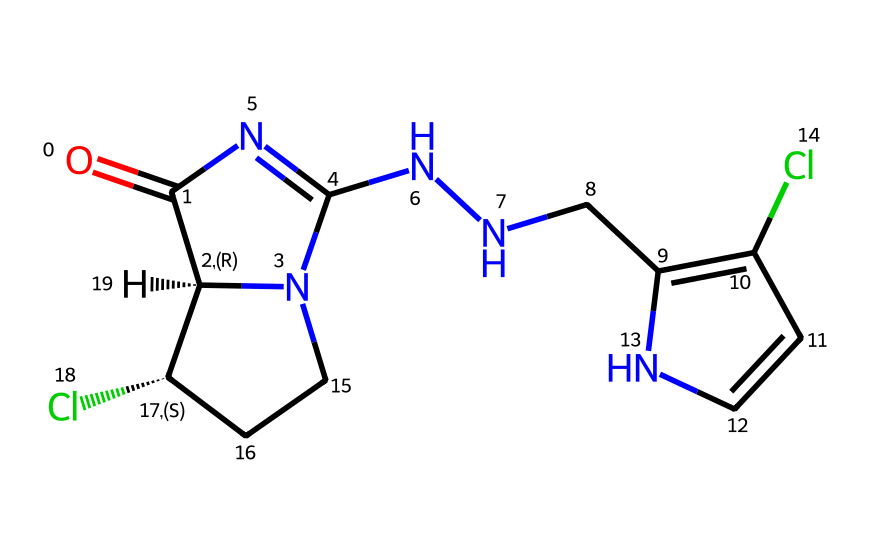What is the molecular formula of this neonicotinoid? To derive the molecular formula, we count all the individual atoms from the SMILES representation. In this structure, there are 12 carbon (C) atoms, 14 hydrogen (H) atoms, 4 nitrogen (N) atoms, and 2 chlorine (Cl) atoms. Thus, the molecular formula is C12H14Cl2N4.
Answer: C12H14Cl2N4 How many rings are present in this neonicotinoid structure? We can identify rings by observing the structure from the SMILES notation. In the representation, we see two pairs of numbers indicating ring closures (1 and 2); therefore, there are two rings in total in this compound.
Answer: 2 Which functional groups are evident in this neonicotinoid? By examining the structure, we look for distinct functional groups. The SMILES suggests both amine (due to the nitrogen atoms), ketone (the carbonyl C=O), and aromatic characteristics (due to the C=C double bond); thus, the functional groups identified are amine, ketone, and aromatic.
Answer: amine, ketone, aromatic What type of chemical is this structure classified as? Considering its structure and the presence of certain functional groups, the compound contains characteristics typical of neonicotinoids, which are synthetic pesticides. Therefore, this structure is classified as a neonicotinoid pesticide based on its functional composition and usage.
Answer: neonicotinoid pesticide What impact does this neonicotinoid have on bee populations? Research indicates that neonicotinoids, like this one, adversely affect bee populations primarily through neurotoxic effects that impair foraging behavior and navigational capabilities. This connection between the chemical's neurotoxic properties and bee health is well-documented in scientific literature.
Answer: neurotoxic effects 